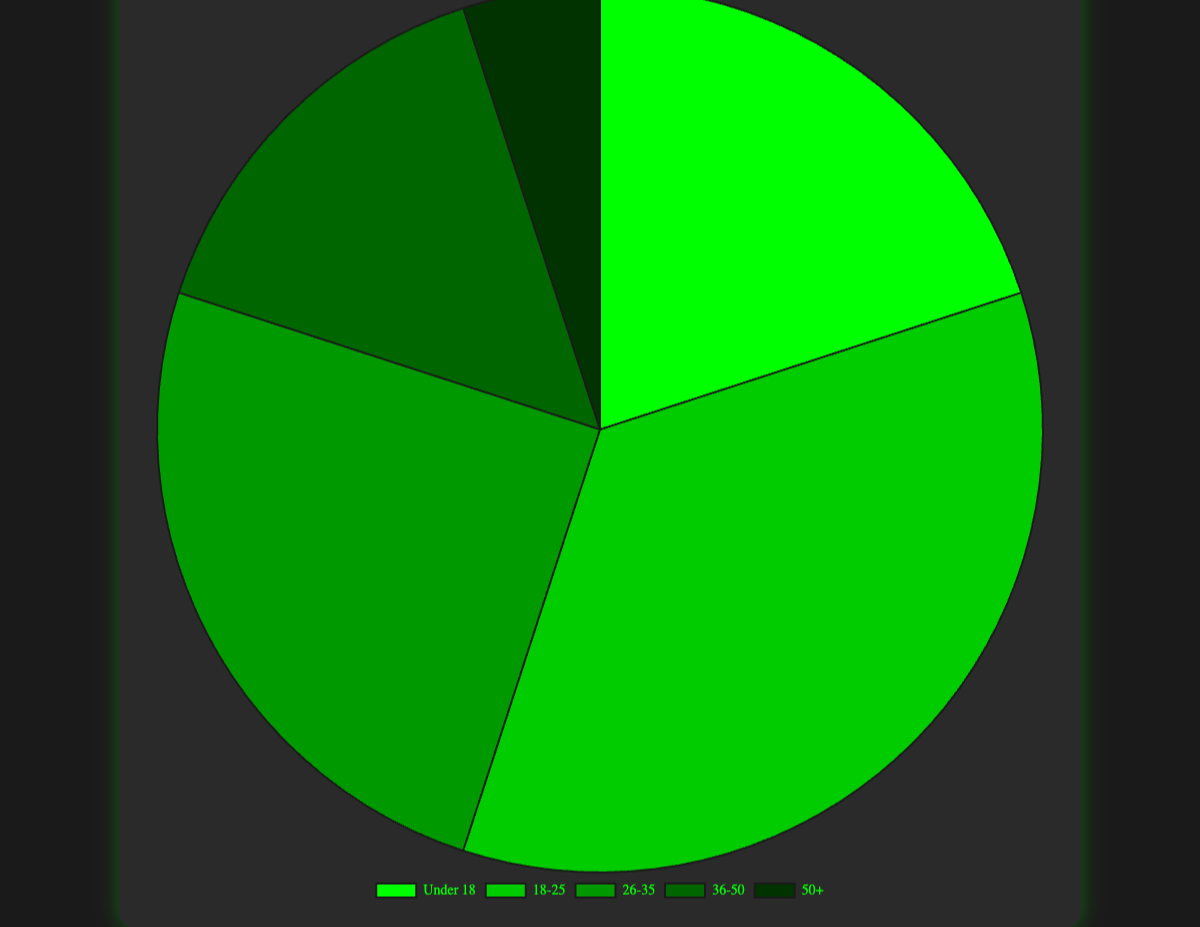What percentage of drone racing enthusiasts are under 26 years old? Combine the percentages for the age groups "Under 18" and "18-25". The sum is 20% + 35% = 55%.
Answer: 55% Which age group constitutes the smallest percentage of drone racing enthusiasts? Identify the age group with the smallest percentage from the pie chart: "50+" with 5%.
Answer: 50+ How much more is the percentage of the "18-25" group compared to the "36-50" group? Subtract the percentage of the "36-50" group from the "18-25" group: 35% - 15% = 20%.
Answer: 20% If you combine the percentages of those aged 25 and younger, how does it compare to the percentage of those aged 26 and older? Sum the percentages for "Under 18" and "18-25": 20% + 35% = 55%. Sum the percentages for "26-35", "36-50", and "50+": 25% + 15% + 5% = 45%. Compare 55% and 45%, showing 25 and younger constitutes more.
Answer: 55% vs 45% What percentage of drone racing enthusiasts are aged between 18 and 35? Combine the percentages for the "18-25" and "26-35" groups: 35% + 25% = 60%.
Answer: 60% Which age group has the second-highest representation among drone racing enthusiasts? From the pie chart, the "26-35" age group is the second highest with 25%, after the "18-25" group.
Answer: 26-35 What is the difference in percentages between the highest and lowest age groups? Subtract the percentage of the smallest group ("50+" with 5%) from the largest group ("18-25" with 35%): 35% - 5% = 30%.
Answer: 30% Which two age groups together make up exactly half of the drone racing enthusiasts? Identify two groups whose combined percentage is 50%. "Under 18" and "26-35" together are 20% + 25% = 45%. "36-50" and "18-25" together make 15% + 35% = 50%. Therefore, "36-50" and "18-25" together make 50%.
Answer: 36-50 and 18-25 